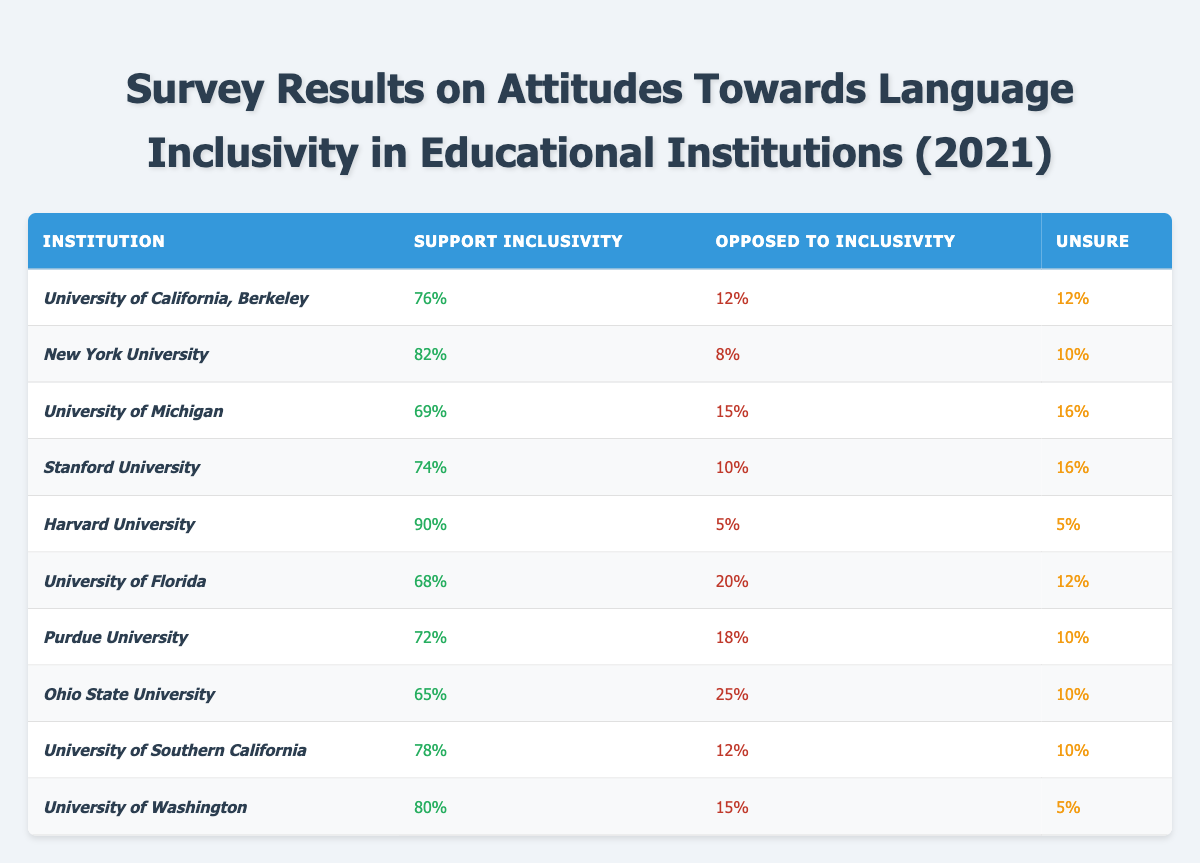What percentage of students at Harvard University support inclusivity? According to the table, the percentage of students who support inclusivity at Harvard University is explicitly stated as 90%.
Answer: 90% Which institution has the lowest percentage of support for language inclusivity? The University of Ohio State has the lowest support for inclusivity at 65%. This information is directly retrievable from the table.
Answer: Ohio State University How many institutions have over 75% support for language inclusivity? From the table, the institutions with support over 75% are: University of California, Berkeley (76%), New York University (82%), Harvard University (90%), University of Southern California (78%), and University of Washington (80%). Counting these gives us 5 institutions.
Answer: 5 What is the average percentage of support for inclusivity across all institutions listed? To find the average: add all support percentages (76 + 82 + 69 + 74 + 90 + 68 + 72 + 65 + 78 + 80 =  785), then divide by the number of institutions (10). So the average is 785/10 = 78.5%.
Answer: 78.5% Which institution has the highest percentage of students opposed to inclusivity? The table shows the largest percentage opposed is at Ohio State University, with 25%. This can be seen directly in the opposition column.
Answer: Ohio State University What is the difference in the percentage of support for inclusivity between Harvard and the University of Florida? Harvard has 90% support while the University of Florida has 68%. The difference is calculated as 90 - 68 = 22%.
Answer: 22% Are more students unsure about inclusivity at the University of Michigan than at Stanford University? The table lists that 16% of University of Michigan students are unsure while only 16% at Stanford University are also unsure. Since both percentages are the same, the answer is no.
Answer: No How many institutions have at least 10% of students unsure about inclusivity? The institutions with 10% or more unsure are: University of Michigan (16%), Stanford University (16%), University of Florida (12%), Purdue University (10%), Ohio State University (10%), and both University of Southern California and University of Washington (10% each); totaling 7 institutions.
Answer: 7 Is it true that New York University has more than 80% support for inclusivity? The table states that New York University has a support percentage of 82%, confirming that it is indeed more than 80%.
Answer: Yes What is the total percentage of students either supportive or opposed to inclusivity at Stanford University? At Stanford University, support for inclusivity is 74% and opposition is 10%. Adding these gives 74 + 10 = 84%.
Answer: 84% 